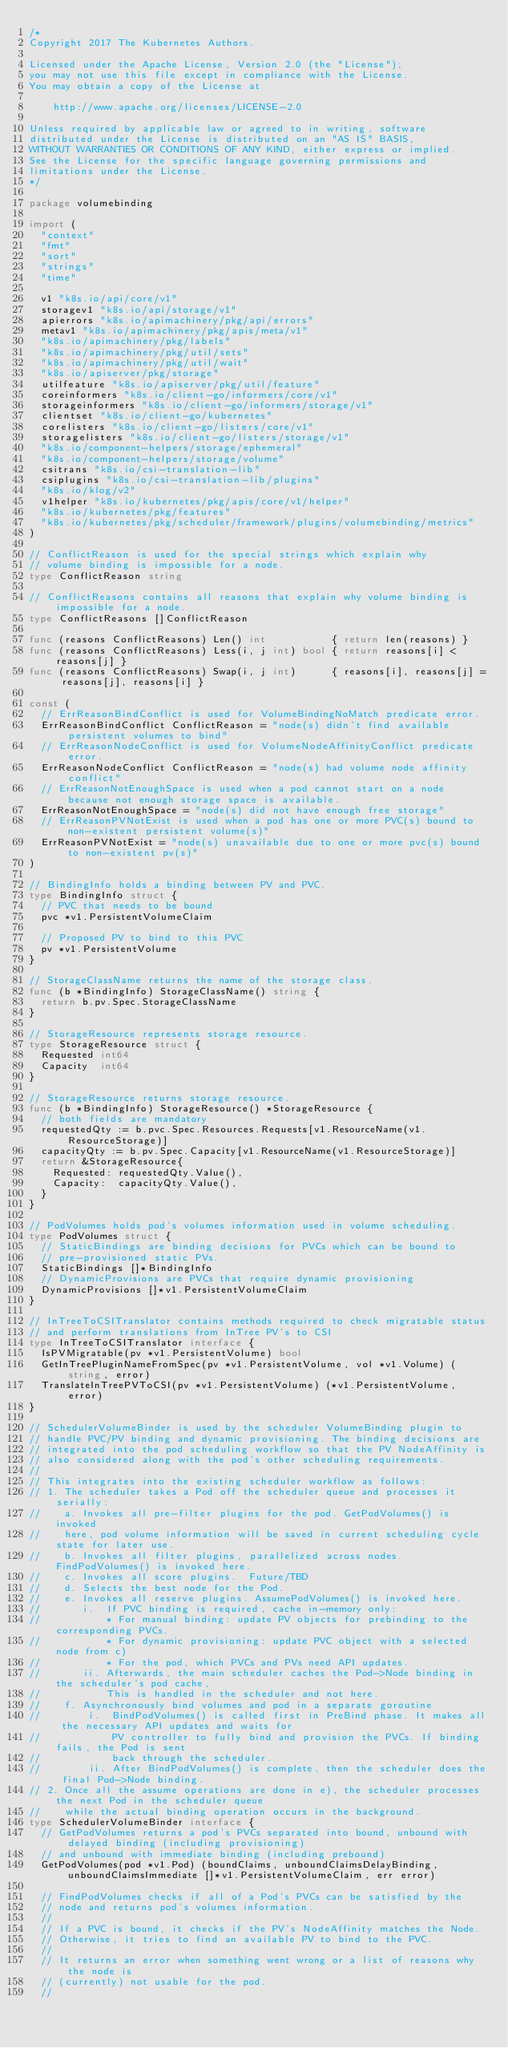Convert code to text. <code><loc_0><loc_0><loc_500><loc_500><_Go_>/*
Copyright 2017 The Kubernetes Authors.

Licensed under the Apache License, Version 2.0 (the "License");
you may not use this file except in compliance with the License.
You may obtain a copy of the License at

    http://www.apache.org/licenses/LICENSE-2.0

Unless required by applicable law or agreed to in writing, software
distributed under the License is distributed on an "AS IS" BASIS,
WITHOUT WARRANTIES OR CONDITIONS OF ANY KIND, either express or implied.
See the License for the specific language governing permissions and
limitations under the License.
*/

package volumebinding

import (
	"context"
	"fmt"
	"sort"
	"strings"
	"time"

	v1 "k8s.io/api/core/v1"
	storagev1 "k8s.io/api/storage/v1"
	apierrors "k8s.io/apimachinery/pkg/api/errors"
	metav1 "k8s.io/apimachinery/pkg/apis/meta/v1"
	"k8s.io/apimachinery/pkg/labels"
	"k8s.io/apimachinery/pkg/util/sets"
	"k8s.io/apimachinery/pkg/util/wait"
	"k8s.io/apiserver/pkg/storage"
	utilfeature "k8s.io/apiserver/pkg/util/feature"
	coreinformers "k8s.io/client-go/informers/core/v1"
	storageinformers "k8s.io/client-go/informers/storage/v1"
	clientset "k8s.io/client-go/kubernetes"
	corelisters "k8s.io/client-go/listers/core/v1"
	storagelisters "k8s.io/client-go/listers/storage/v1"
	"k8s.io/component-helpers/storage/ephemeral"
	"k8s.io/component-helpers/storage/volume"
	csitrans "k8s.io/csi-translation-lib"
	csiplugins "k8s.io/csi-translation-lib/plugins"
	"k8s.io/klog/v2"
	v1helper "k8s.io/kubernetes/pkg/apis/core/v1/helper"
	"k8s.io/kubernetes/pkg/features"
	"k8s.io/kubernetes/pkg/scheduler/framework/plugins/volumebinding/metrics"
)

// ConflictReason is used for the special strings which explain why
// volume binding is impossible for a node.
type ConflictReason string

// ConflictReasons contains all reasons that explain why volume binding is impossible for a node.
type ConflictReasons []ConflictReason

func (reasons ConflictReasons) Len() int           { return len(reasons) }
func (reasons ConflictReasons) Less(i, j int) bool { return reasons[i] < reasons[j] }
func (reasons ConflictReasons) Swap(i, j int)      { reasons[i], reasons[j] = reasons[j], reasons[i] }

const (
	// ErrReasonBindConflict is used for VolumeBindingNoMatch predicate error.
	ErrReasonBindConflict ConflictReason = "node(s) didn't find available persistent volumes to bind"
	// ErrReasonNodeConflict is used for VolumeNodeAffinityConflict predicate error.
	ErrReasonNodeConflict ConflictReason = "node(s) had volume node affinity conflict"
	// ErrReasonNotEnoughSpace is used when a pod cannot start on a node because not enough storage space is available.
	ErrReasonNotEnoughSpace = "node(s) did not have enough free storage"
	// ErrReasonPVNotExist is used when a pod has one or more PVC(s) bound to non-existent persistent volume(s)"
	ErrReasonPVNotExist = "node(s) unavailable due to one or more pvc(s) bound to non-existent pv(s)"
)

// BindingInfo holds a binding between PV and PVC.
type BindingInfo struct {
	// PVC that needs to be bound
	pvc *v1.PersistentVolumeClaim

	// Proposed PV to bind to this PVC
	pv *v1.PersistentVolume
}

// StorageClassName returns the name of the storage class.
func (b *BindingInfo) StorageClassName() string {
	return b.pv.Spec.StorageClassName
}

// StorageResource represents storage resource.
type StorageResource struct {
	Requested int64
	Capacity  int64
}

// StorageResource returns storage resource.
func (b *BindingInfo) StorageResource() *StorageResource {
	// both fields are mandatory
	requestedQty := b.pvc.Spec.Resources.Requests[v1.ResourceName(v1.ResourceStorage)]
	capacityQty := b.pv.Spec.Capacity[v1.ResourceName(v1.ResourceStorage)]
	return &StorageResource{
		Requested: requestedQty.Value(),
		Capacity:  capacityQty.Value(),
	}
}

// PodVolumes holds pod's volumes information used in volume scheduling.
type PodVolumes struct {
	// StaticBindings are binding decisions for PVCs which can be bound to
	// pre-provisioned static PVs.
	StaticBindings []*BindingInfo
	// DynamicProvisions are PVCs that require dynamic provisioning
	DynamicProvisions []*v1.PersistentVolumeClaim
}

// InTreeToCSITranslator contains methods required to check migratable status
// and perform translations from InTree PV's to CSI
type InTreeToCSITranslator interface {
	IsPVMigratable(pv *v1.PersistentVolume) bool
	GetInTreePluginNameFromSpec(pv *v1.PersistentVolume, vol *v1.Volume) (string, error)
	TranslateInTreePVToCSI(pv *v1.PersistentVolume) (*v1.PersistentVolume, error)
}

// SchedulerVolumeBinder is used by the scheduler VolumeBinding plugin to
// handle PVC/PV binding and dynamic provisioning. The binding decisions are
// integrated into the pod scheduling workflow so that the PV NodeAffinity is
// also considered along with the pod's other scheduling requirements.
//
// This integrates into the existing scheduler workflow as follows:
// 1. The scheduler takes a Pod off the scheduler queue and processes it serially:
//    a. Invokes all pre-filter plugins for the pod. GetPodVolumes() is invoked
//    here, pod volume information will be saved in current scheduling cycle state for later use.
//    b. Invokes all filter plugins, parallelized across nodes.  FindPodVolumes() is invoked here.
//    c. Invokes all score plugins.  Future/TBD
//    d. Selects the best node for the Pod.
//    e. Invokes all reserve plugins. AssumePodVolumes() is invoked here.
//       i.  If PVC binding is required, cache in-memory only:
//           * For manual binding: update PV objects for prebinding to the corresponding PVCs.
//           * For dynamic provisioning: update PVC object with a selected node from c)
//           * For the pod, which PVCs and PVs need API updates.
//       ii. Afterwards, the main scheduler caches the Pod->Node binding in the scheduler's pod cache,
//           This is handled in the scheduler and not here.
//    f. Asynchronously bind volumes and pod in a separate goroutine
//        i.  BindPodVolumes() is called first in PreBind phase. It makes all the necessary API updates and waits for
//            PV controller to fully bind and provision the PVCs. If binding fails, the Pod is sent
//            back through the scheduler.
//        ii. After BindPodVolumes() is complete, then the scheduler does the final Pod->Node binding.
// 2. Once all the assume operations are done in e), the scheduler processes the next Pod in the scheduler queue
//    while the actual binding operation occurs in the background.
type SchedulerVolumeBinder interface {
	// GetPodVolumes returns a pod's PVCs separated into bound, unbound with delayed binding (including provisioning)
	// and unbound with immediate binding (including prebound)
	GetPodVolumes(pod *v1.Pod) (boundClaims, unboundClaimsDelayBinding, unboundClaimsImmediate []*v1.PersistentVolumeClaim, err error)

	// FindPodVolumes checks if all of a Pod's PVCs can be satisfied by the
	// node and returns pod's volumes information.
	//
	// If a PVC is bound, it checks if the PV's NodeAffinity matches the Node.
	// Otherwise, it tries to find an available PV to bind to the PVC.
	//
	// It returns an error when something went wrong or a list of reasons why the node is
	// (currently) not usable for the pod.
	//</code> 